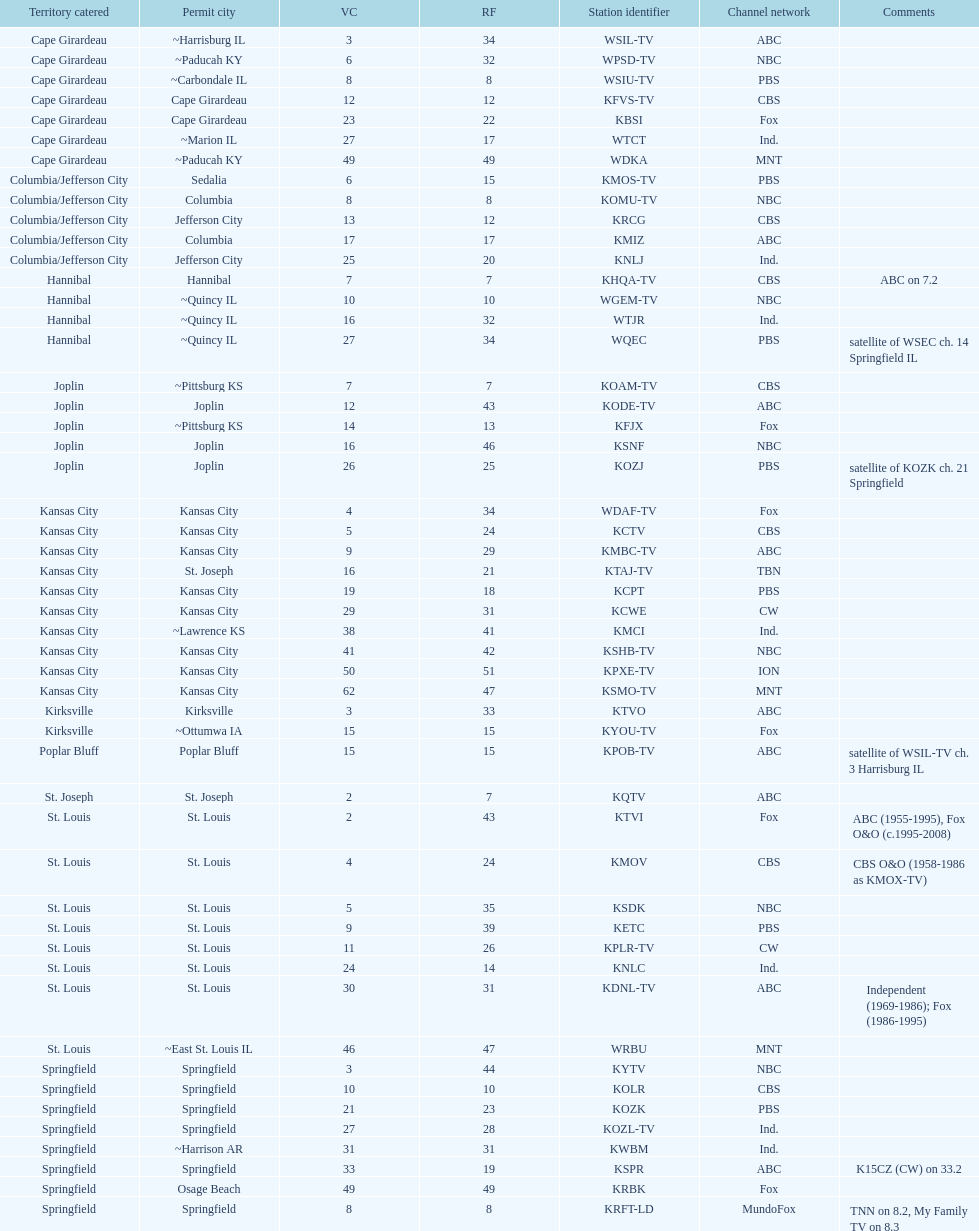What is the aggregate amount of stations providing service in the cape girardeau area? 7. 